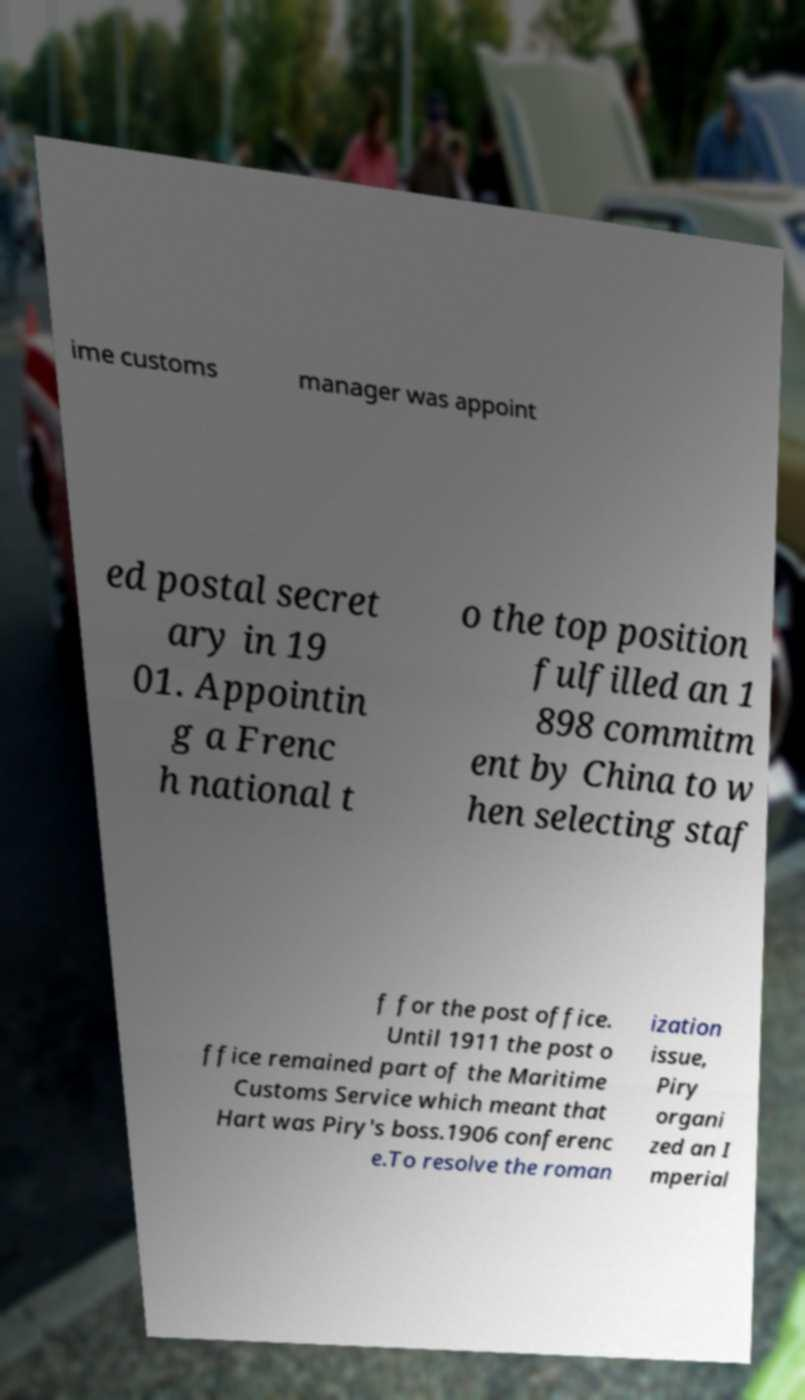Please read and relay the text visible in this image. What does it say? ime customs manager was appoint ed postal secret ary in 19 01. Appointin g a Frenc h national t o the top position fulfilled an 1 898 commitm ent by China to w hen selecting staf f for the post office. Until 1911 the post o ffice remained part of the Maritime Customs Service which meant that Hart was Piry's boss.1906 conferenc e.To resolve the roman ization issue, Piry organi zed an I mperial 